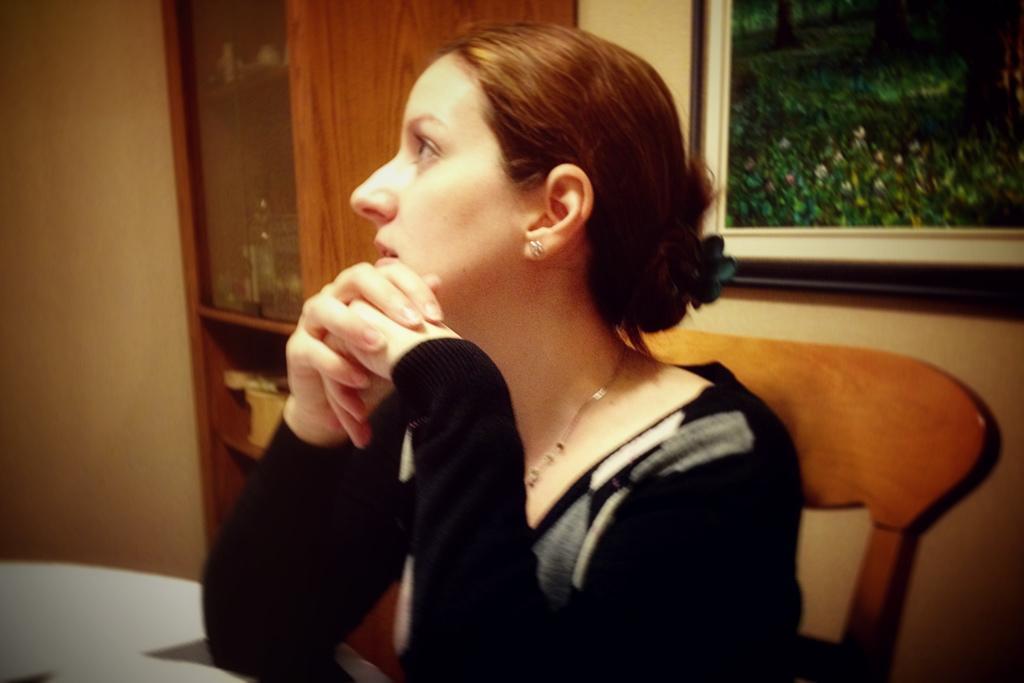Please provide a concise description of this image. This is the woman sitting on the chair. It might be a table. I think this is a wooden rack with the objects in it. This is a photo frame, which is attached to the wall. 